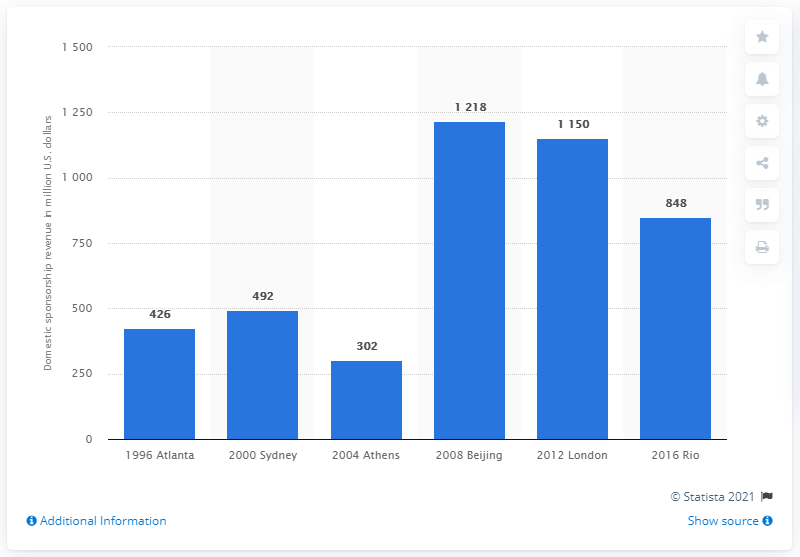Identify some key points in this picture. The Rio de Janeiro 2016 Olympic Games generated approximately 848 million U.S. dollars. 